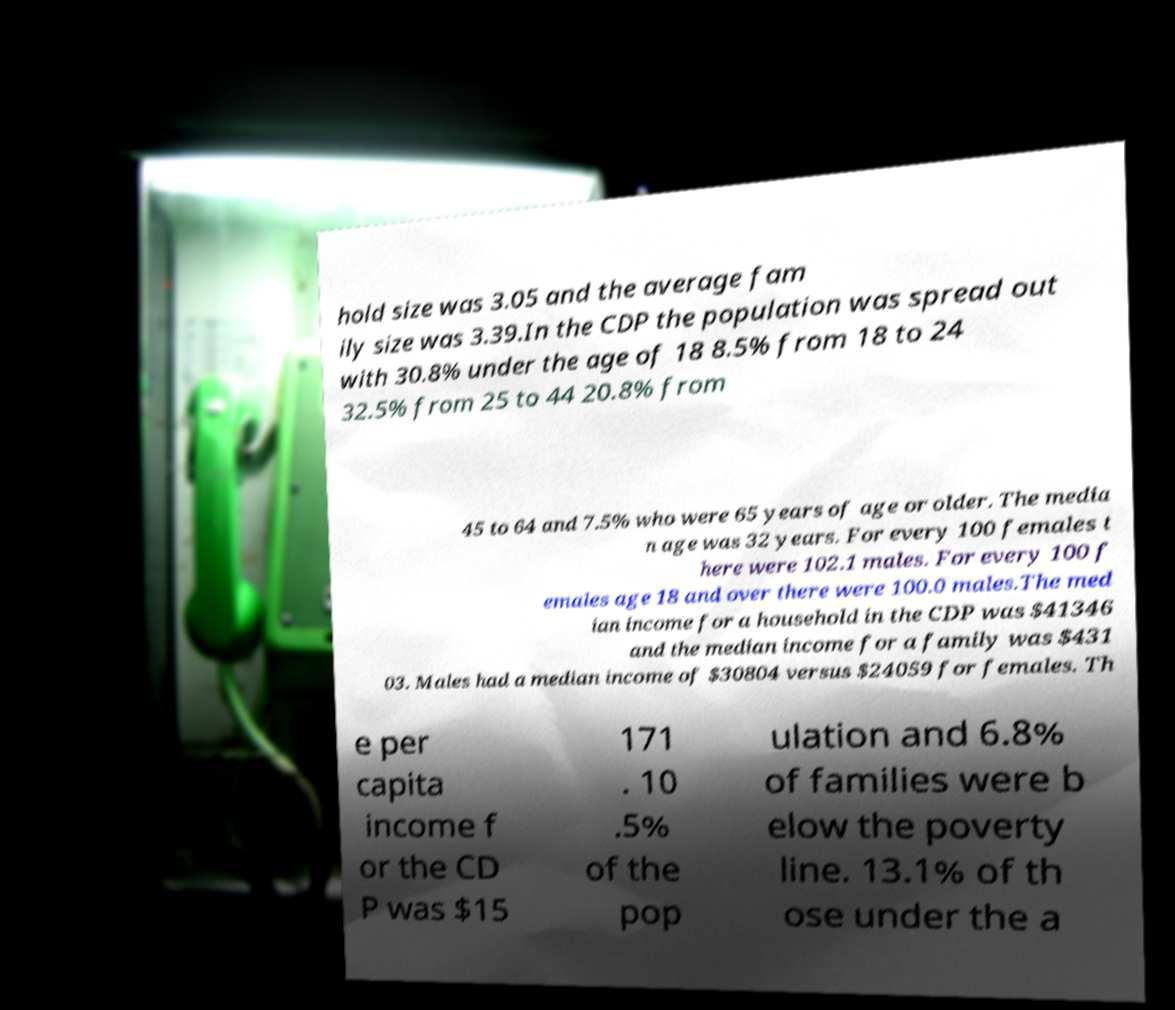Please read and relay the text visible in this image. What does it say? hold size was 3.05 and the average fam ily size was 3.39.In the CDP the population was spread out with 30.8% under the age of 18 8.5% from 18 to 24 32.5% from 25 to 44 20.8% from 45 to 64 and 7.5% who were 65 years of age or older. The media n age was 32 years. For every 100 females t here were 102.1 males. For every 100 f emales age 18 and over there were 100.0 males.The med ian income for a household in the CDP was $41346 and the median income for a family was $431 03. Males had a median income of $30804 versus $24059 for females. Th e per capita income f or the CD P was $15 171 . 10 .5% of the pop ulation and 6.8% of families were b elow the poverty line. 13.1% of th ose under the a 